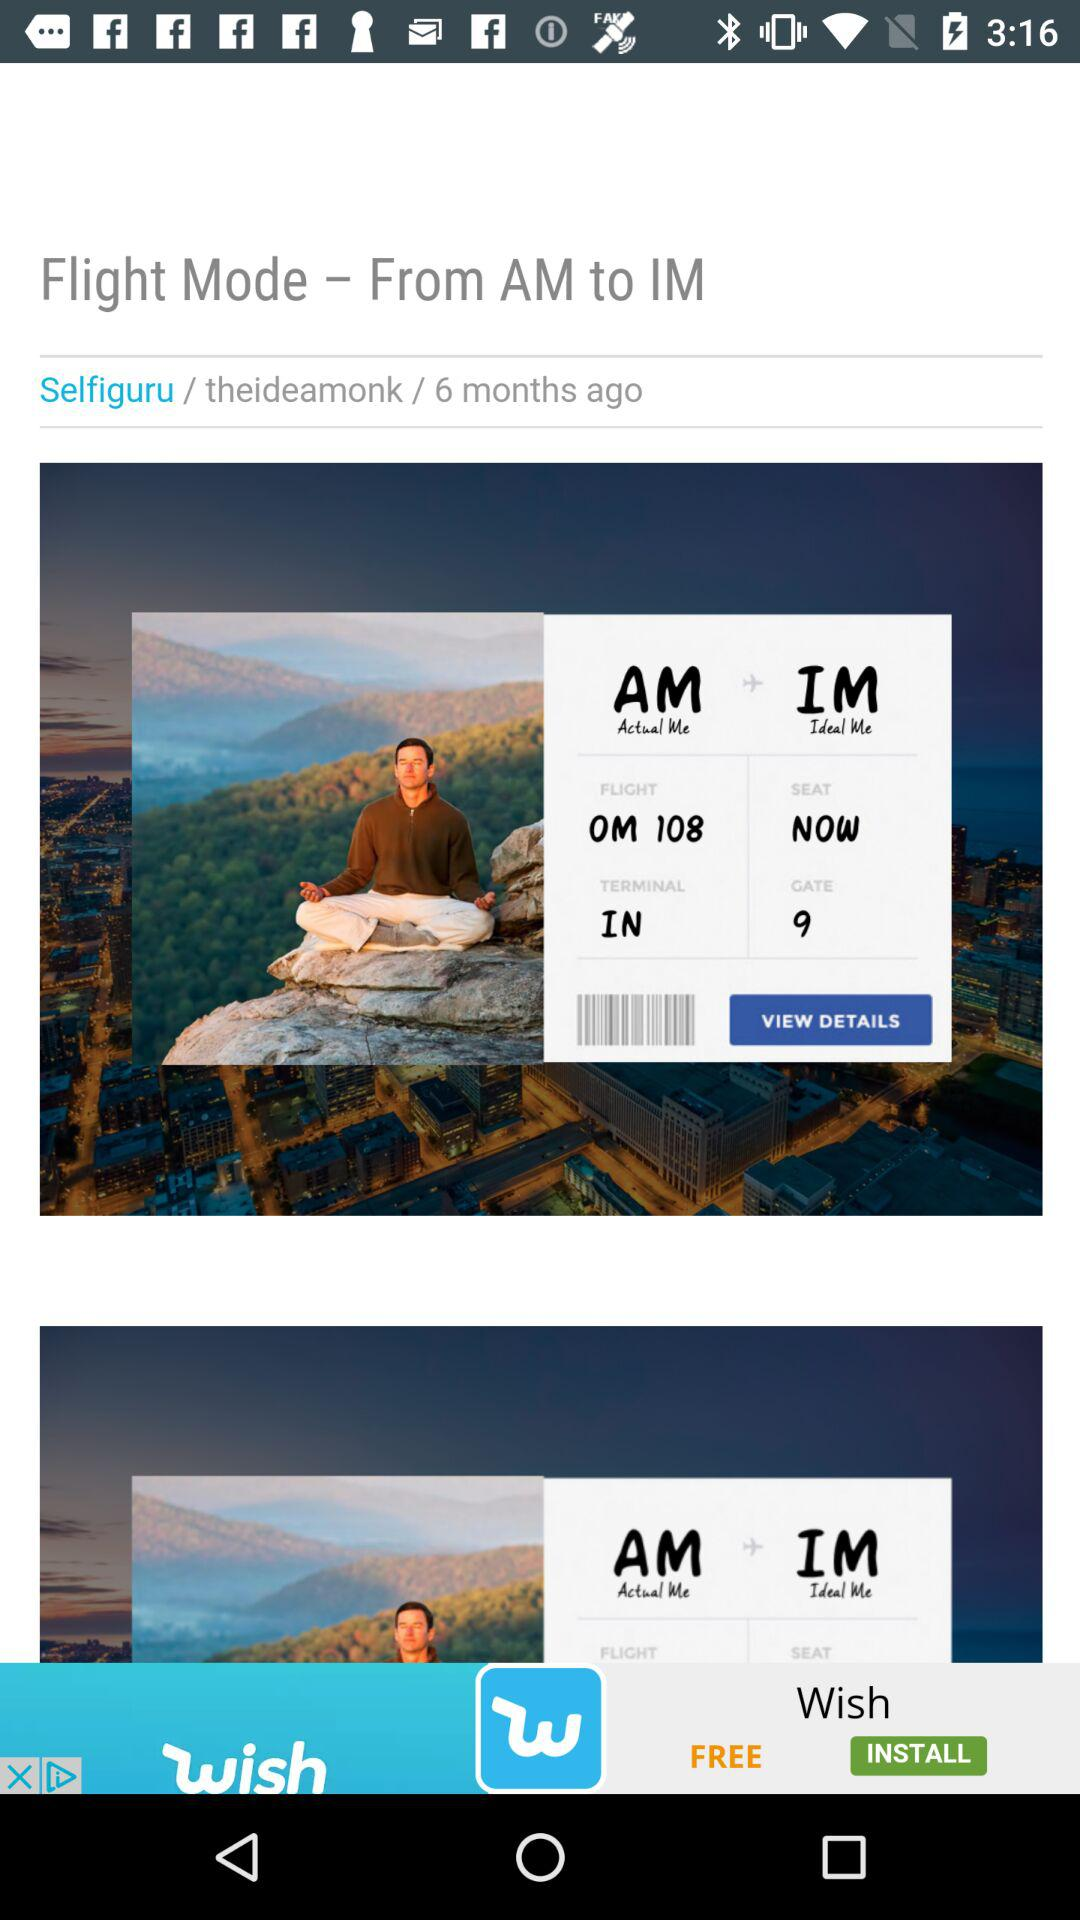What gate number has been given? The given gate number is 9. 